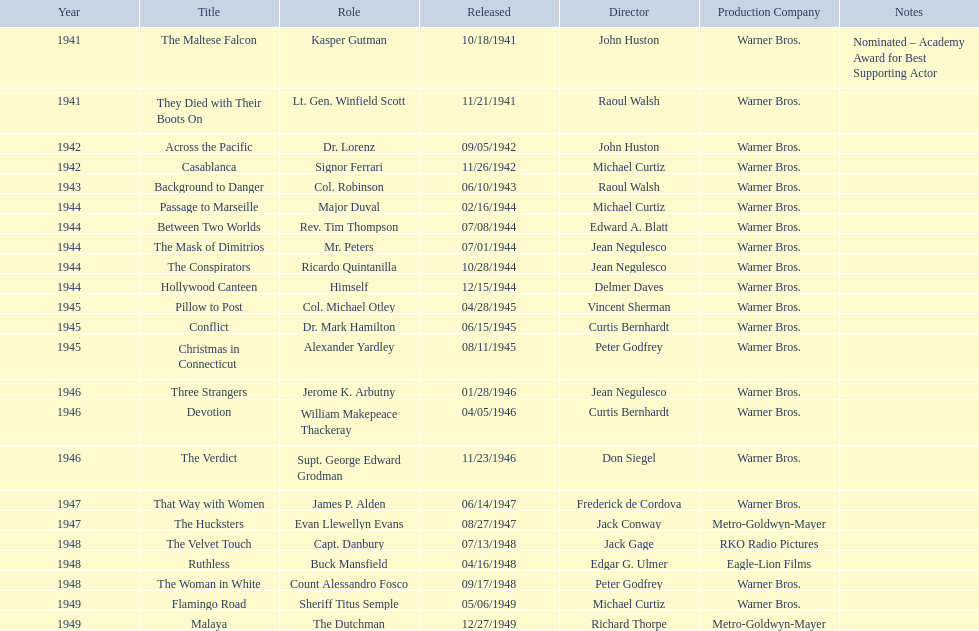What are the movies? The Maltese Falcon, They Died with Their Boots On, Across the Pacific, Casablanca, Background to Danger, Passage to Marseille, Between Two Worlds, The Mask of Dimitrios, The Conspirators, Hollywood Canteen, Pillow to Post, Conflict, Christmas in Connecticut, Three Strangers, Devotion, The Verdict, That Way with Women, The Hucksters, The Velvet Touch, Ruthless, The Woman in White, Flamingo Road, Malaya. Of these, for which did he get nominated for an oscar? The Maltese Falcon. 